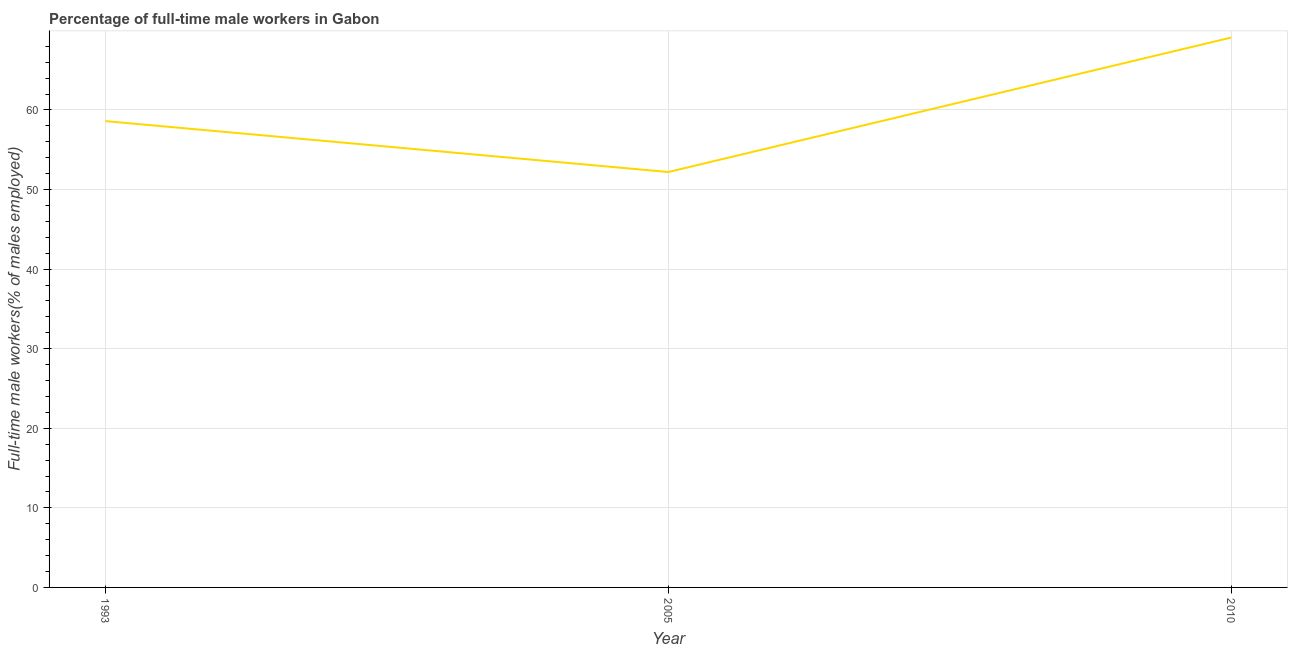What is the percentage of full-time male workers in 2010?
Offer a terse response. 69.1. Across all years, what is the maximum percentage of full-time male workers?
Offer a terse response. 69.1. Across all years, what is the minimum percentage of full-time male workers?
Your answer should be very brief. 52.2. In which year was the percentage of full-time male workers maximum?
Keep it short and to the point. 2010. What is the sum of the percentage of full-time male workers?
Make the answer very short. 179.9. What is the difference between the percentage of full-time male workers in 1993 and 2010?
Offer a very short reply. -10.5. What is the average percentage of full-time male workers per year?
Offer a very short reply. 59.97. What is the median percentage of full-time male workers?
Keep it short and to the point. 58.6. What is the ratio of the percentage of full-time male workers in 1993 to that in 2010?
Ensure brevity in your answer.  0.85. Is the percentage of full-time male workers in 1993 less than that in 2010?
Provide a succinct answer. Yes. Is the difference between the percentage of full-time male workers in 1993 and 2005 greater than the difference between any two years?
Your response must be concise. No. What is the difference between the highest and the second highest percentage of full-time male workers?
Give a very brief answer. 10.5. Is the sum of the percentage of full-time male workers in 1993 and 2005 greater than the maximum percentage of full-time male workers across all years?
Offer a very short reply. Yes. What is the difference between the highest and the lowest percentage of full-time male workers?
Provide a short and direct response. 16.9. Does the percentage of full-time male workers monotonically increase over the years?
Offer a very short reply. No. What is the difference between two consecutive major ticks on the Y-axis?
Your answer should be very brief. 10. Does the graph contain any zero values?
Your answer should be very brief. No. What is the title of the graph?
Your answer should be compact. Percentage of full-time male workers in Gabon. What is the label or title of the Y-axis?
Your answer should be compact. Full-time male workers(% of males employed). What is the Full-time male workers(% of males employed) in 1993?
Keep it short and to the point. 58.6. What is the Full-time male workers(% of males employed) of 2005?
Provide a short and direct response. 52.2. What is the Full-time male workers(% of males employed) of 2010?
Provide a short and direct response. 69.1. What is the difference between the Full-time male workers(% of males employed) in 1993 and 2005?
Your answer should be very brief. 6.4. What is the difference between the Full-time male workers(% of males employed) in 1993 and 2010?
Provide a succinct answer. -10.5. What is the difference between the Full-time male workers(% of males employed) in 2005 and 2010?
Give a very brief answer. -16.9. What is the ratio of the Full-time male workers(% of males employed) in 1993 to that in 2005?
Provide a short and direct response. 1.12. What is the ratio of the Full-time male workers(% of males employed) in 1993 to that in 2010?
Your answer should be compact. 0.85. What is the ratio of the Full-time male workers(% of males employed) in 2005 to that in 2010?
Keep it short and to the point. 0.76. 